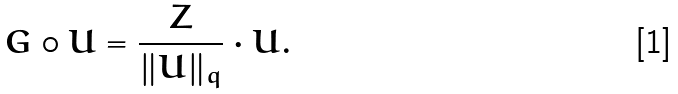<formula> <loc_0><loc_0><loc_500><loc_500>G \circ U = \frac { Z } { \| U \| _ { q } } \cdot U .</formula> 